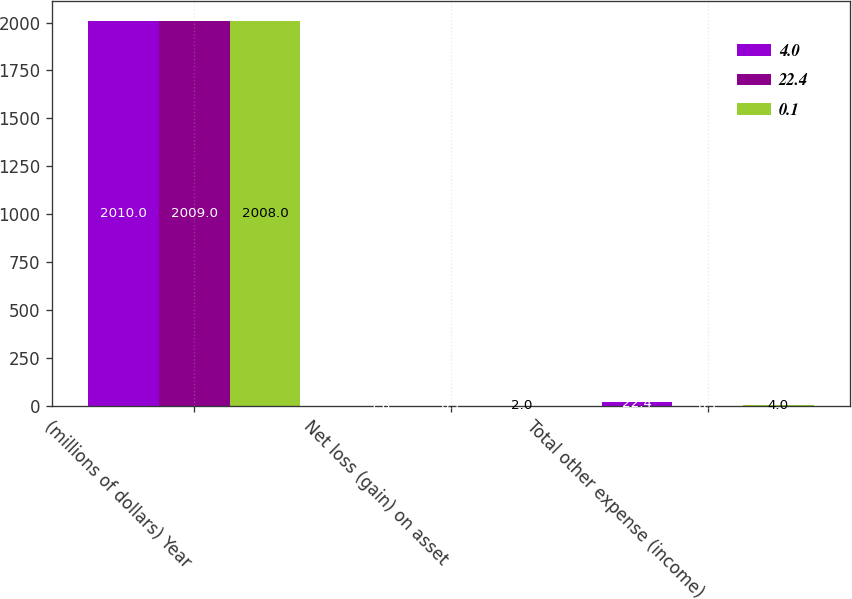Convert chart. <chart><loc_0><loc_0><loc_500><loc_500><stacked_bar_chart><ecel><fcel>(millions of dollars) Year<fcel>Net loss (gain) on asset<fcel>Total other expense (income)<nl><fcel>4<fcel>2010<fcel>1.8<fcel>22.4<nl><fcel>22.4<fcel>2009<fcel>0.1<fcel>0.1<nl><fcel>0.1<fcel>2008<fcel>2<fcel>4<nl></chart> 